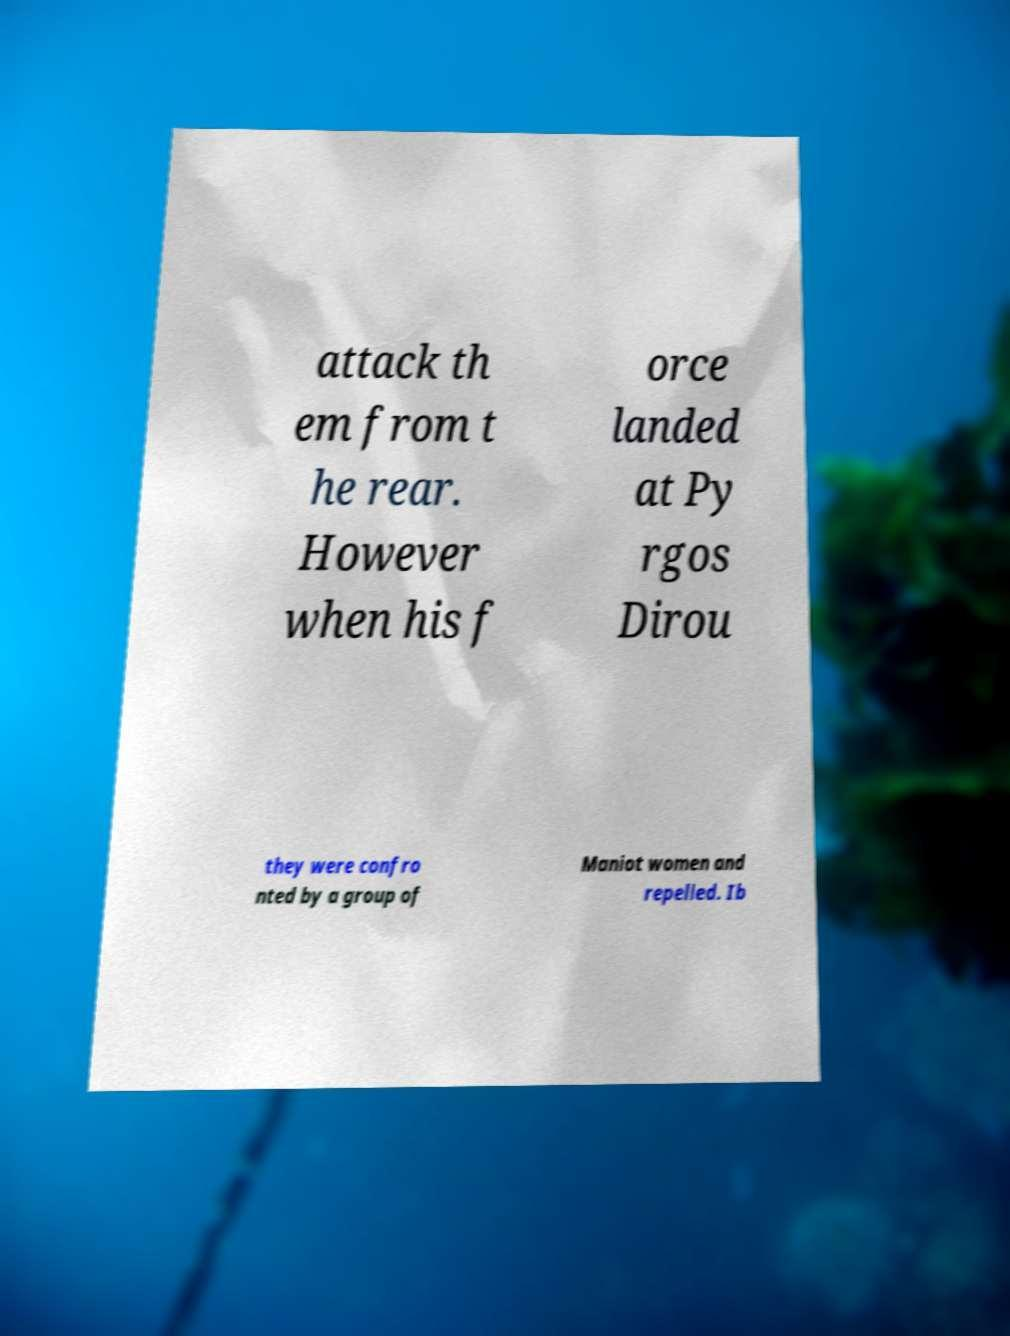I need the written content from this picture converted into text. Can you do that? attack th em from t he rear. However when his f orce landed at Py rgos Dirou they were confro nted by a group of Maniot women and repelled. Ib 